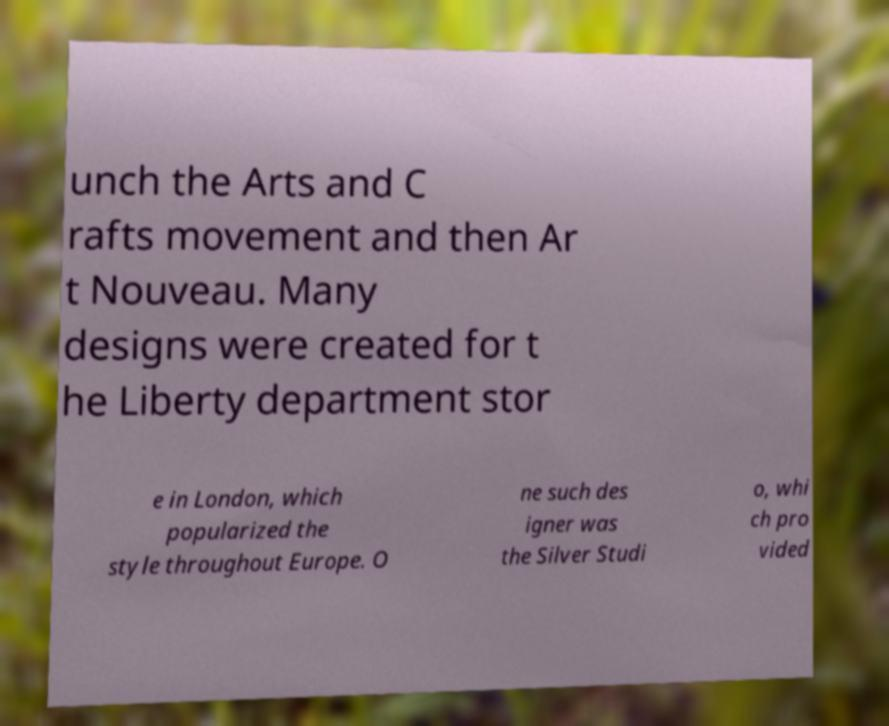Could you extract and type out the text from this image? unch the Arts and C rafts movement and then Ar t Nouveau. Many designs were created for t he Liberty department stor e in London, which popularized the style throughout Europe. O ne such des igner was the Silver Studi o, whi ch pro vided 